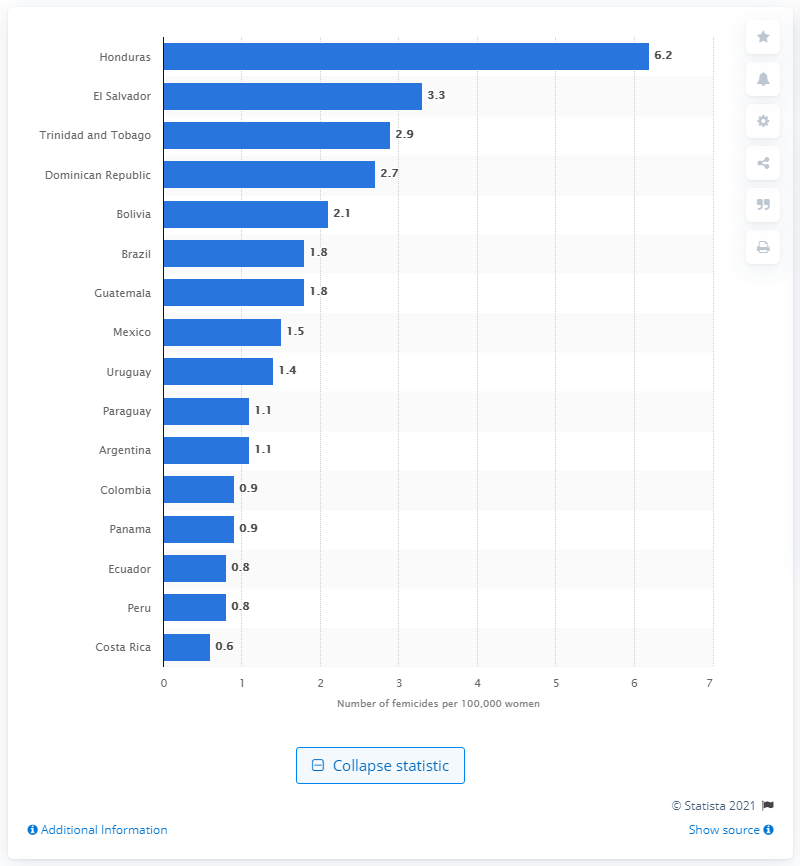Draw attention to some important aspects in this diagram. According to the data, Costa Rica had the lowest femicide rate among all countries. Honduras had the highest femicide rate among all Latin American countries as of 2019, according to recent data. Brazil had the largest number of femicide cases in the region in 2019, according to the latest statistics. 